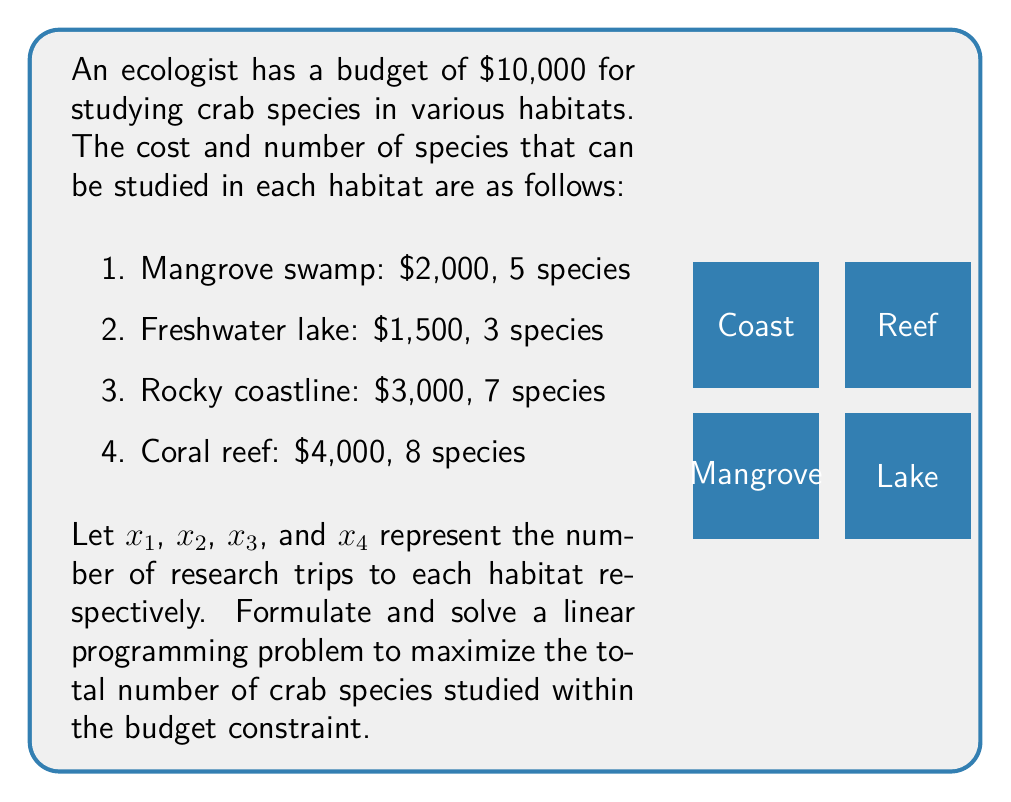Give your solution to this math problem. Let's approach this step-by-step:

1) First, we need to formulate the objective function. We want to maximize the total number of species studied:

   Maximize: $Z = 5x_1 + 3x_2 + 7x_3 + 8x_4$

2) Next, we need to define the constraints:

   Budget constraint: $2000x_1 + 1500x_2 + 3000x_3 + 4000x_4 \leq 10000$
   Non-negativity: $x_1, x_2, x_3, x_4 \geq 0$
   Integer constraint: $x_1, x_2, x_3, x_4$ are integers

3) This is an integer linear programming problem. We can solve it using the simplex method and then round down to the nearest integer solution.

4) Using a linear programming solver, we get the following optimal solution:
   $x_1 = 1, x_2 = 2, x_3 = 1, x_4 = 1$

5) Let's verify the solution:
   Budget used: $2000(1) + 1500(2) + 3000(1) + 4000(1) = 10000$
   Total species studied: $5(1) + 3(2) + 7(1) + 8(1) = 26$

6) This solution maximizes the number of species studied (26) while exactly meeting the budget constraint ($10,000).
Answer: $x_1 = 1, x_2 = 2, x_3 = 1, x_4 = 1$; 26 species 